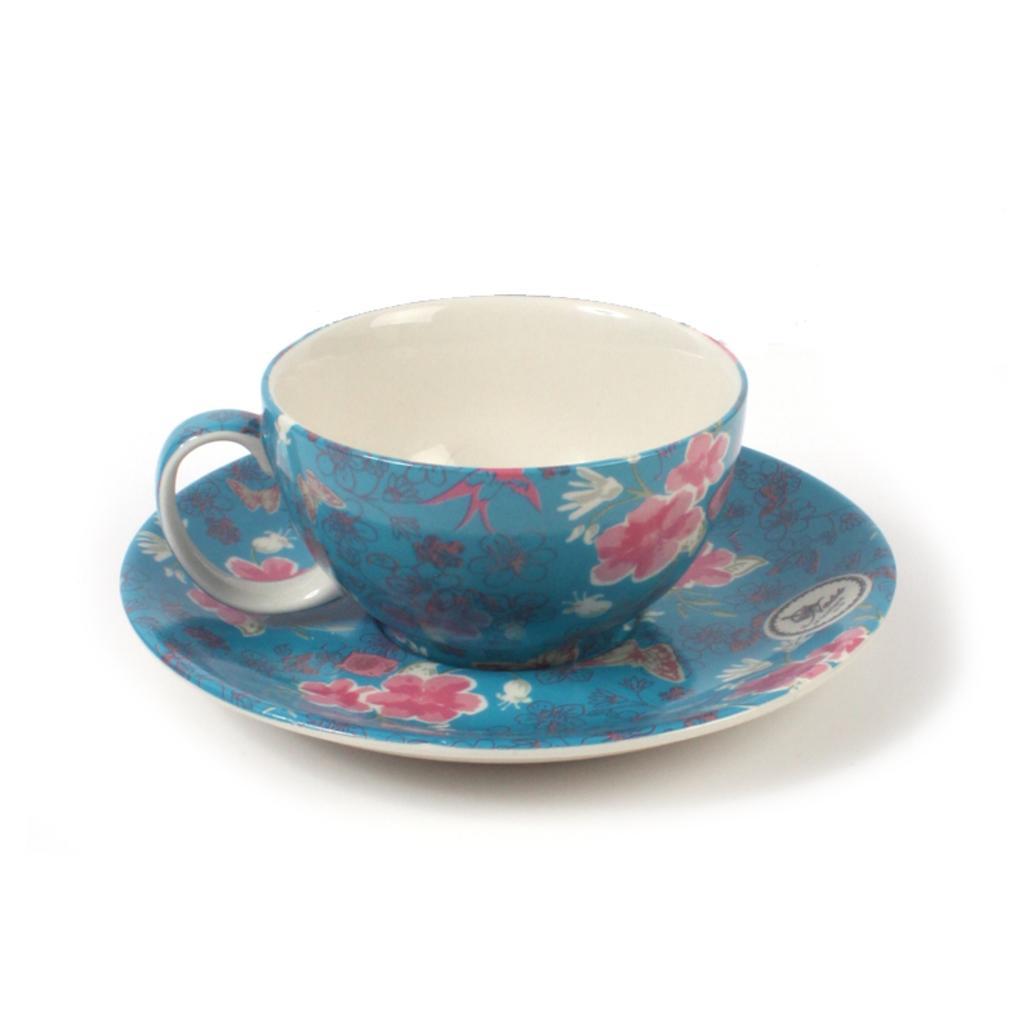Describe this image in one or two sentences. In this image we can see a cup on the saucer and a white background. 